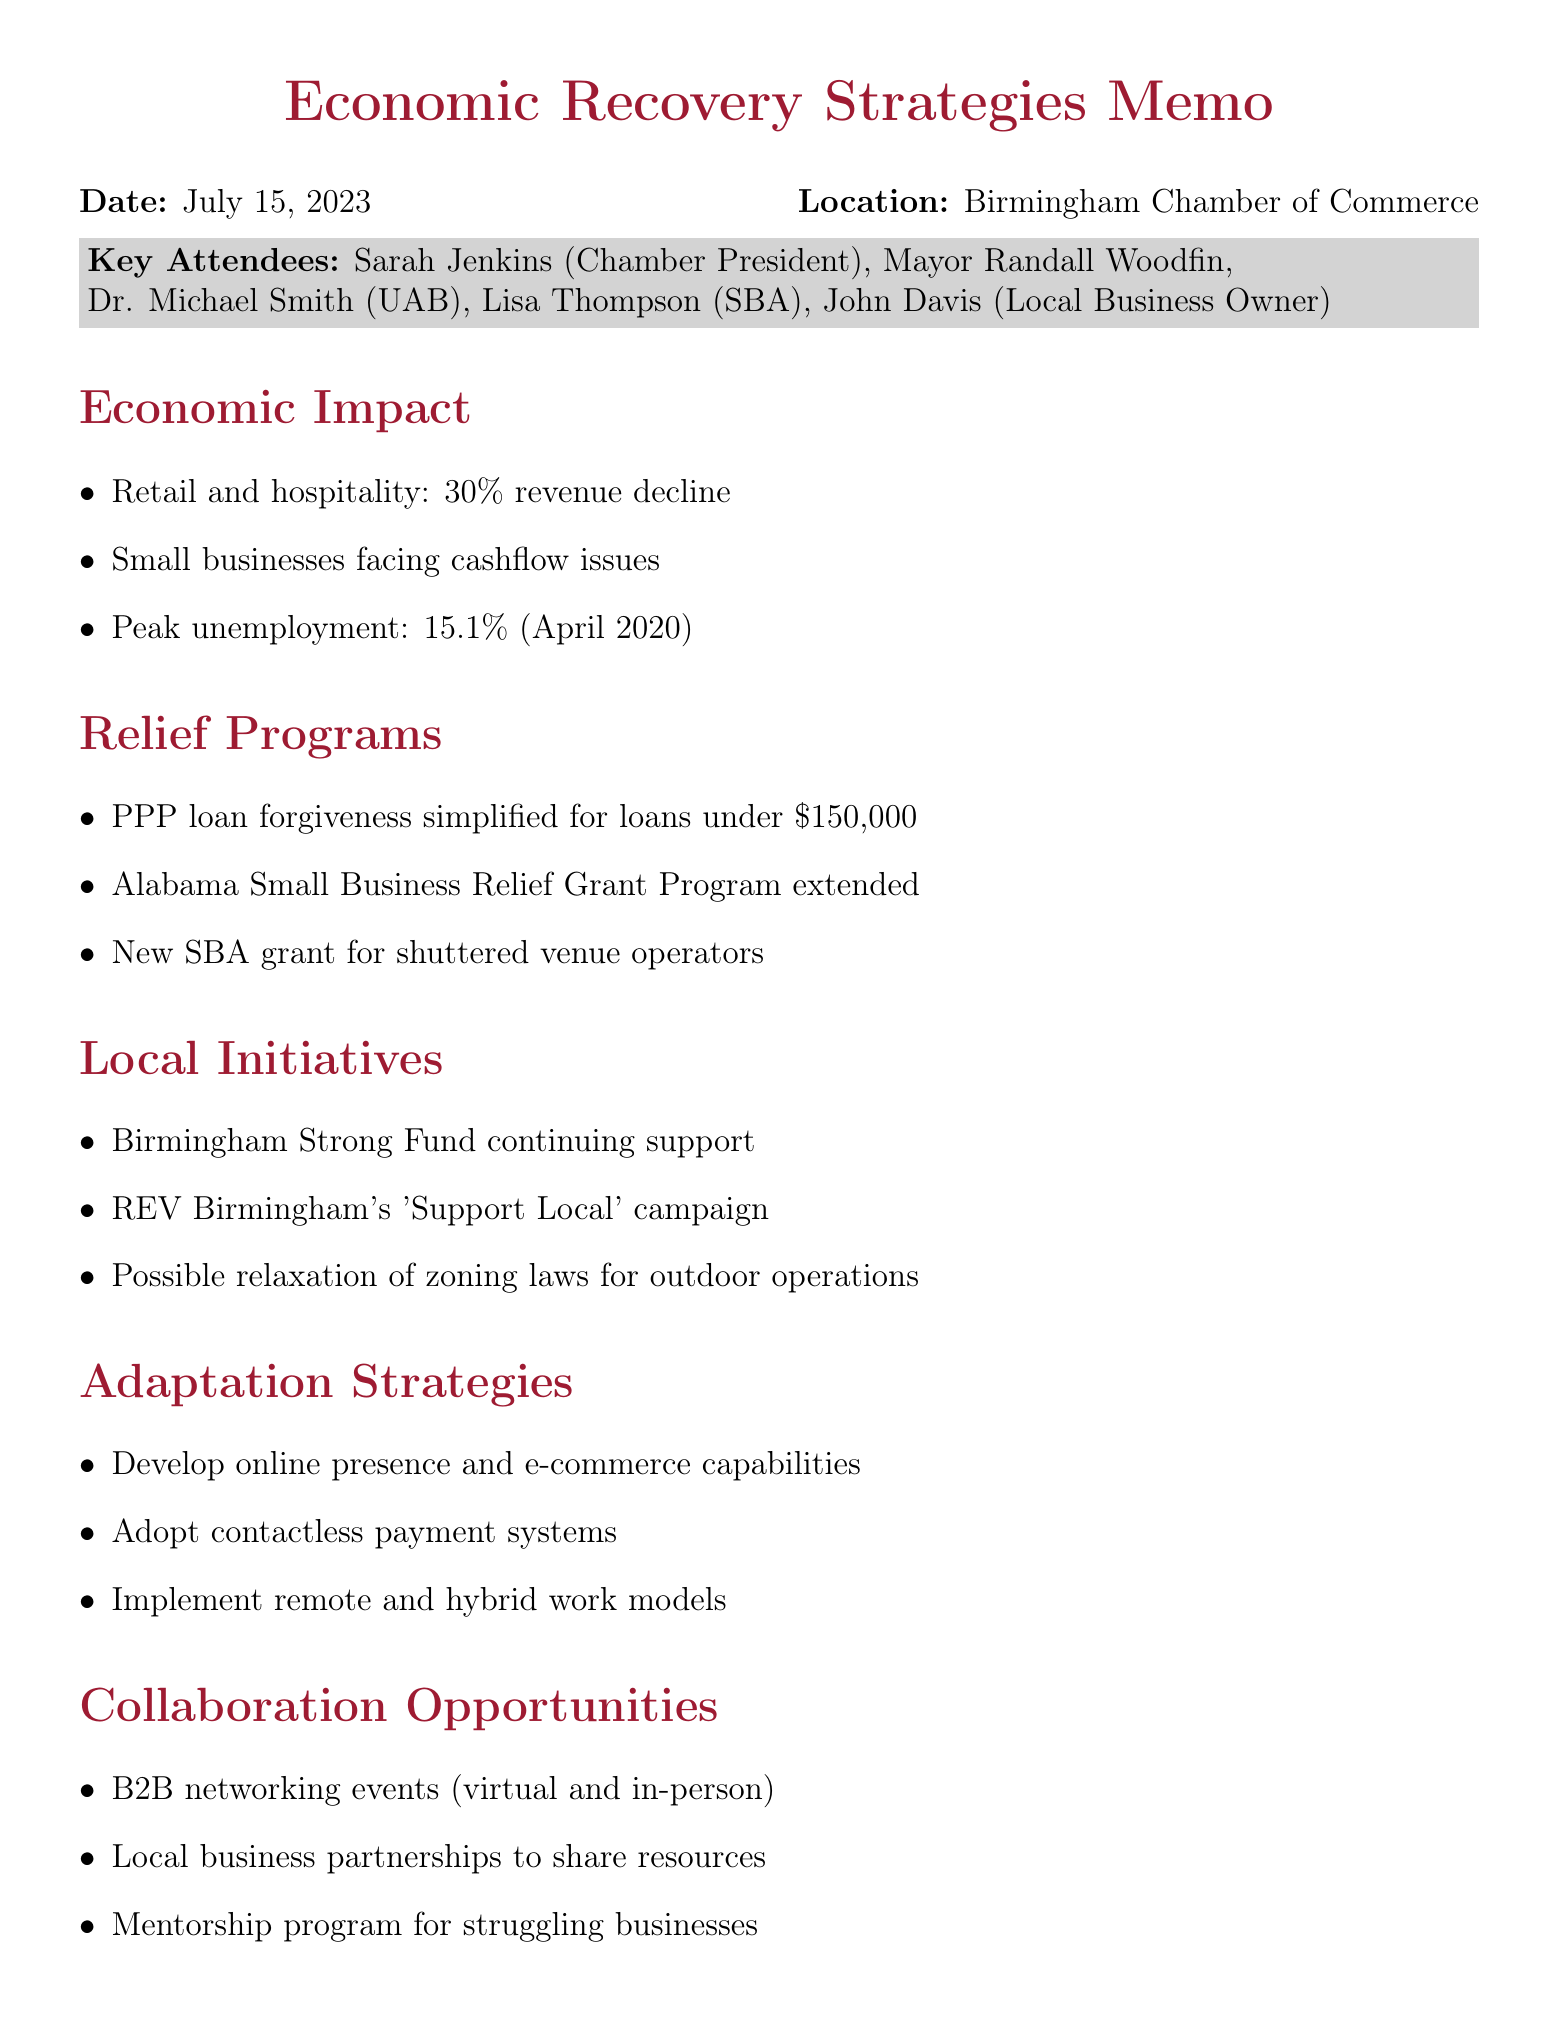What is the date of the meeting? The date of the meeting is specified in the document header.
Answer: July 15, 2023 Who is the Chamber President? The document lists the key attendees, including the Chamber President.
Answer: Sarah Jenkins What percentage did the retail and hospitality sectors decline? The document provides specific statistics on revenue decline in the economic impact section.
Answer: 30% What is the peak unemployment rate in Jefferson County? The document states the unemployment rate during a specific period.
Answer: 15.1% What funding program was extended for Alabama small businesses? The document includes updates on relief programs being discussed.
Answer: Alabama Small Business Relief Grant Program What campaign is REV Birmingham launching? This is mentioned under local initiatives to support businesses.
Answer: Support Local What key action is the Mayor's office undertaking? The action items section lists responsibilities assigned to various parties, including the Mayor's office.
Answer: Expedite outdoor business operation requests What is a suggested adaptation strategy for businesses? The document lists strategies for adapting to the new normal.
Answer: Develop online presence and e-commerce capabilities What type of events will the Chamber facilitate? The document specifies the types of collaboration opportunities being offered by the Chamber.
Answer: B2B networking events 